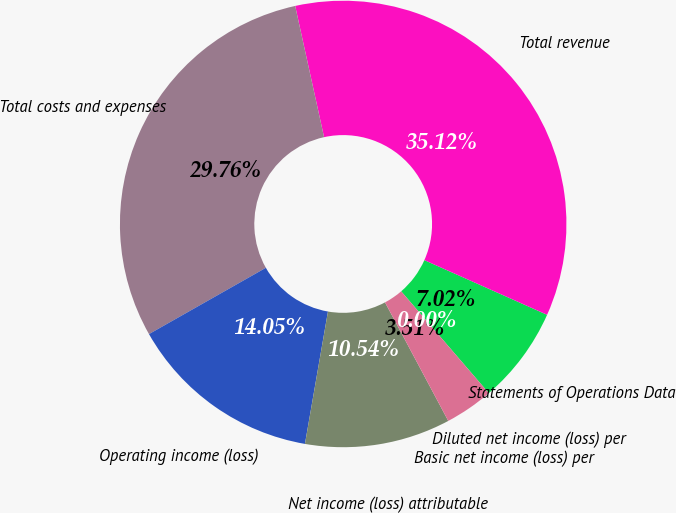<chart> <loc_0><loc_0><loc_500><loc_500><pie_chart><fcel>Statements of Operations Data<fcel>Total revenue<fcel>Total costs and expenses<fcel>Operating income (loss)<fcel>Net income (loss) attributable<fcel>Basic net income (loss) per<fcel>Diluted net income (loss) per<nl><fcel>7.02%<fcel>35.12%<fcel>29.76%<fcel>14.05%<fcel>10.54%<fcel>3.51%<fcel>0.0%<nl></chart> 